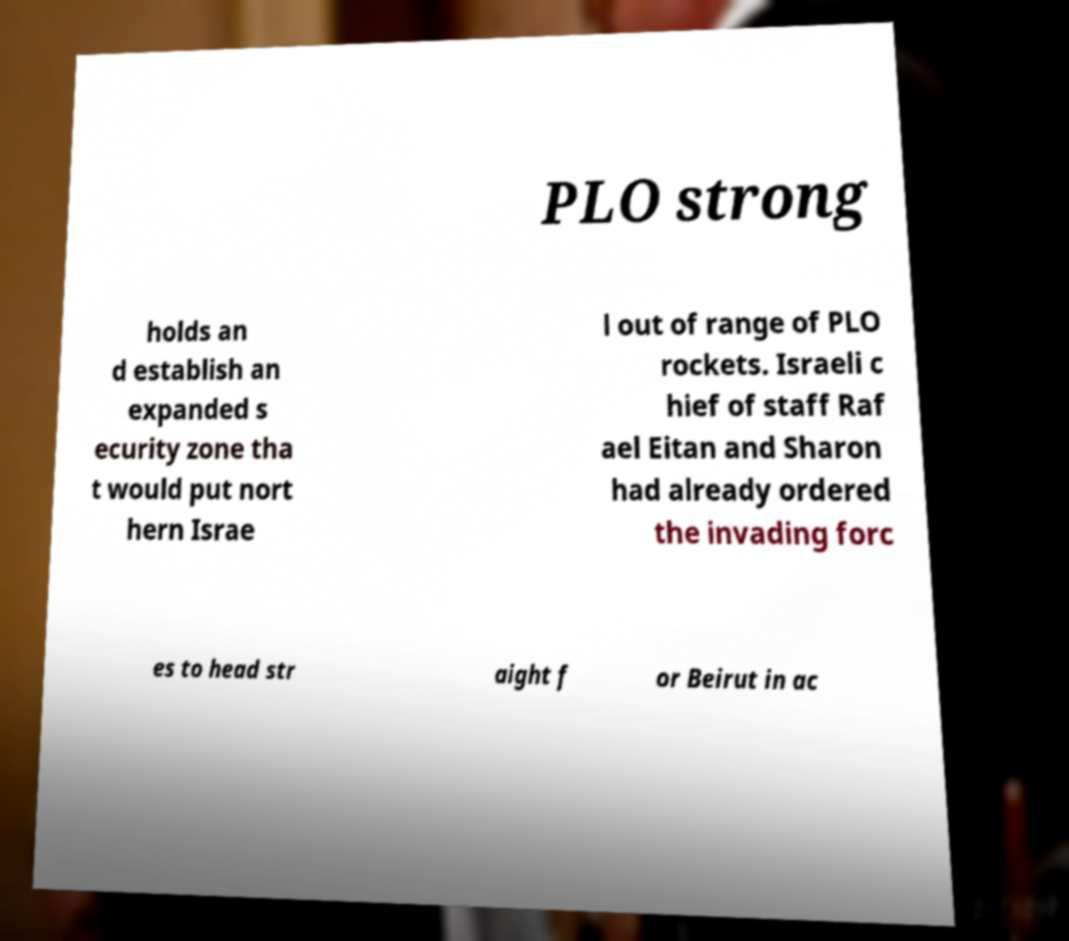I need the written content from this picture converted into text. Can you do that? PLO strong holds an d establish an expanded s ecurity zone tha t would put nort hern Israe l out of range of PLO rockets. Israeli c hief of staff Raf ael Eitan and Sharon had already ordered the invading forc es to head str aight f or Beirut in ac 